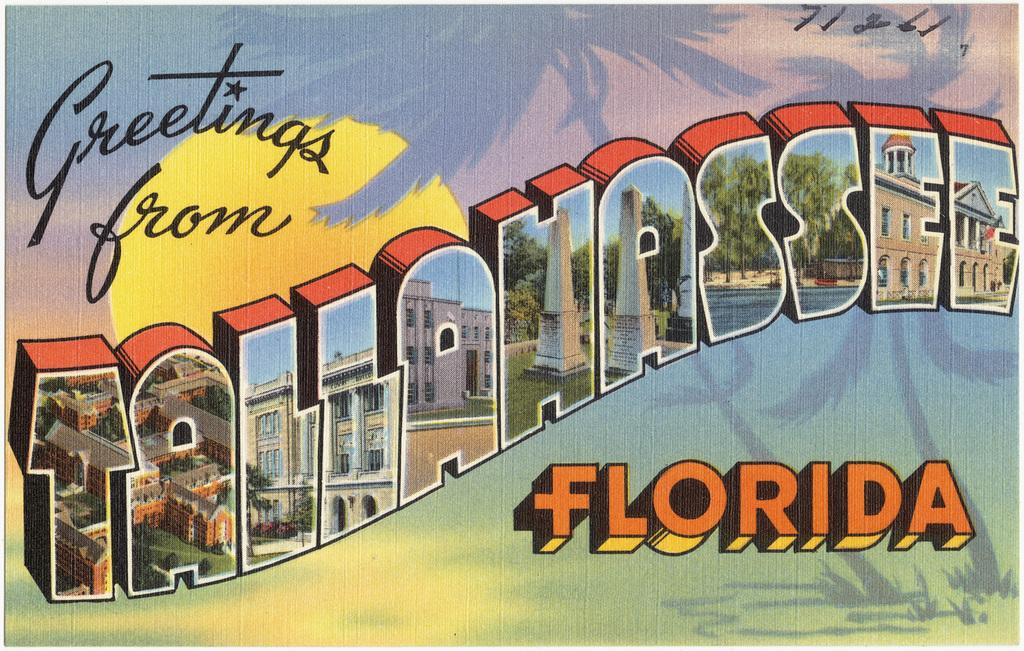<image>
Render a clear and concise summary of the photo. A postcard from Tallahassee Florida with lots of colorful imagery. 